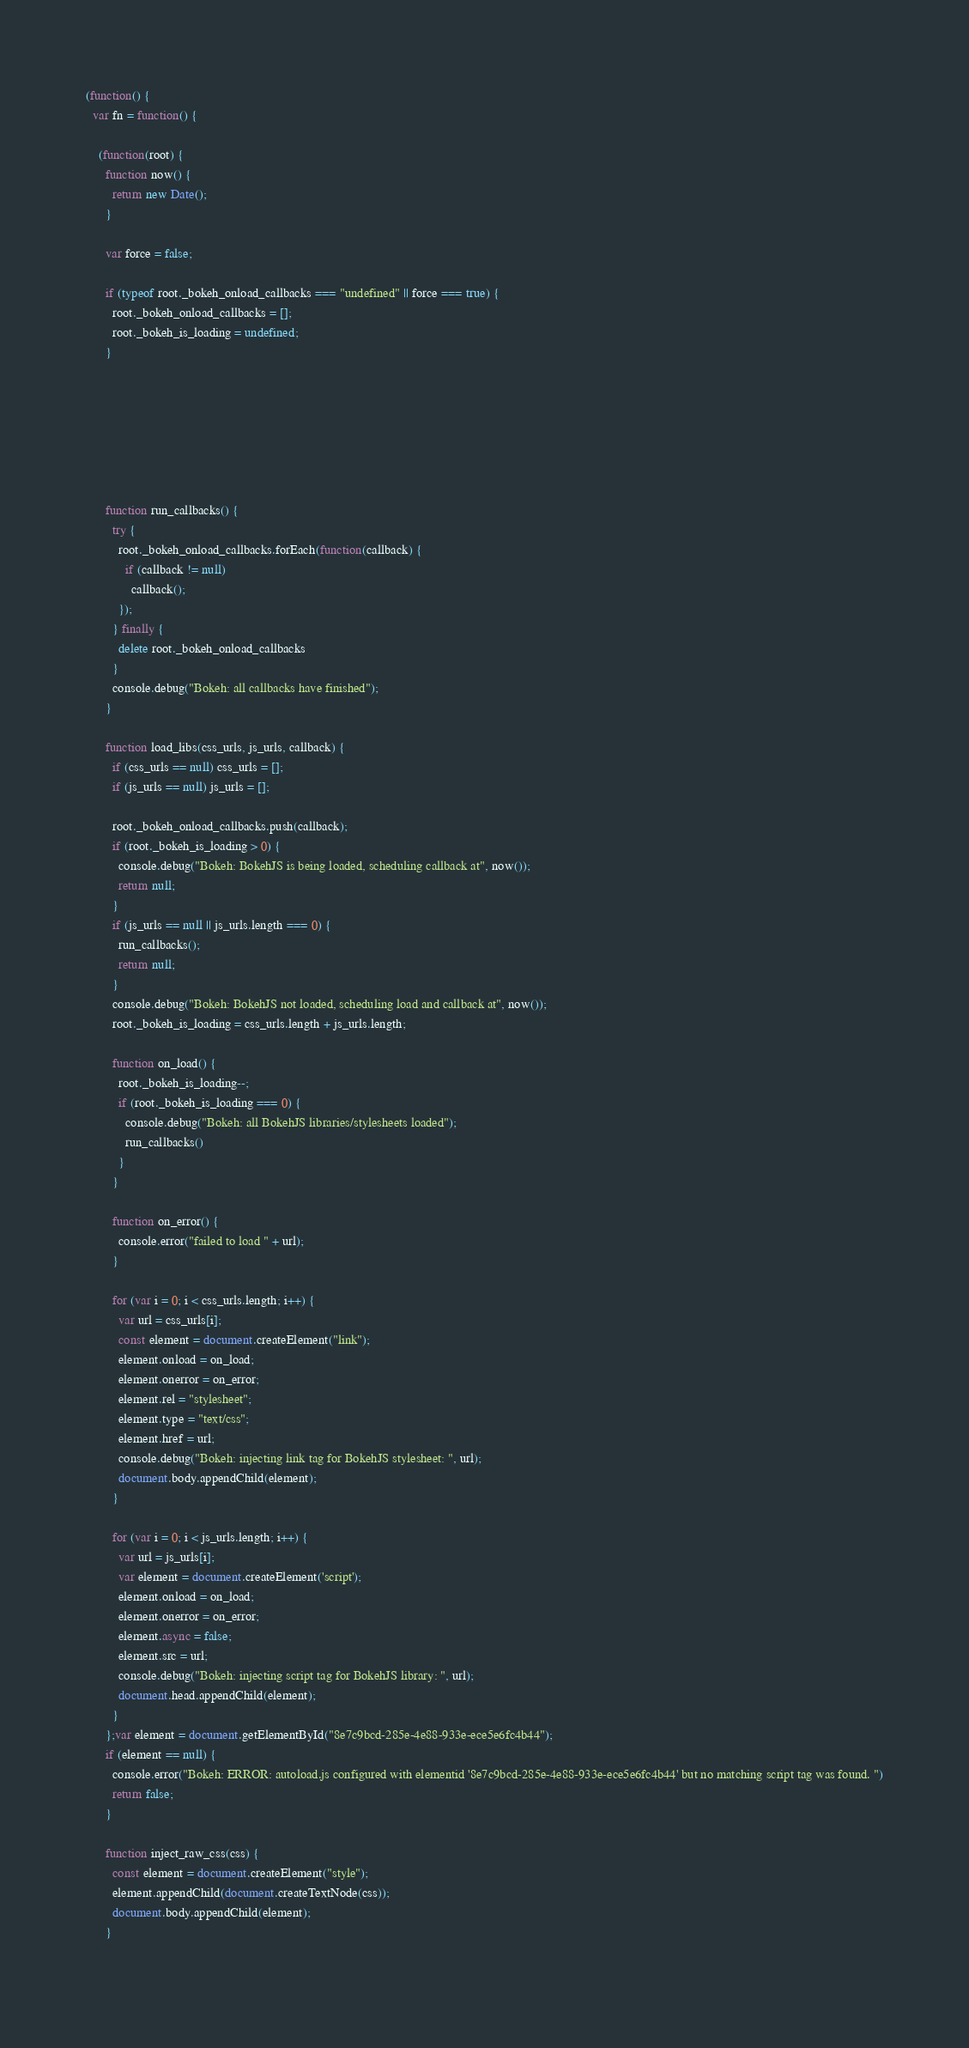Convert code to text. <code><loc_0><loc_0><loc_500><loc_500><_JavaScript_>(function() {
  var fn = function() {
    
    (function(root) {
      function now() {
        return new Date();
      }
    
      var force = false;
    
      if (typeof root._bokeh_onload_callbacks === "undefined" || force === true) {
        root._bokeh_onload_callbacks = [];
        root._bokeh_is_loading = undefined;
      }
    
      
      
    
      
      
    
      function run_callbacks() {
        try {
          root._bokeh_onload_callbacks.forEach(function(callback) {
            if (callback != null)
              callback();
          });
        } finally {
          delete root._bokeh_onload_callbacks
        }
        console.debug("Bokeh: all callbacks have finished");
      }
    
      function load_libs(css_urls, js_urls, callback) {
        if (css_urls == null) css_urls = [];
        if (js_urls == null) js_urls = [];
    
        root._bokeh_onload_callbacks.push(callback);
        if (root._bokeh_is_loading > 0) {
          console.debug("Bokeh: BokehJS is being loaded, scheduling callback at", now());
          return null;
        }
        if (js_urls == null || js_urls.length === 0) {
          run_callbacks();
          return null;
        }
        console.debug("Bokeh: BokehJS not loaded, scheduling load and callback at", now());
        root._bokeh_is_loading = css_urls.length + js_urls.length;
    
        function on_load() {
          root._bokeh_is_loading--;
          if (root._bokeh_is_loading === 0) {
            console.debug("Bokeh: all BokehJS libraries/stylesheets loaded");
            run_callbacks()
          }
        }
    
        function on_error() {
          console.error("failed to load " + url);
        }
    
        for (var i = 0; i < css_urls.length; i++) {
          var url = css_urls[i];
          const element = document.createElement("link");
          element.onload = on_load;
          element.onerror = on_error;
          element.rel = "stylesheet";
          element.type = "text/css";
          element.href = url;
          console.debug("Bokeh: injecting link tag for BokehJS stylesheet: ", url);
          document.body.appendChild(element);
        }
    
        for (var i = 0; i < js_urls.length; i++) {
          var url = js_urls[i];
          var element = document.createElement('script');
          element.onload = on_load;
          element.onerror = on_error;
          element.async = false;
          element.src = url;
          console.debug("Bokeh: injecting script tag for BokehJS library: ", url);
          document.head.appendChild(element);
        }
      };var element = document.getElementById("8e7c9bcd-285e-4e88-933e-ece5e6fc4b44");
      if (element == null) {
        console.error("Bokeh: ERROR: autoload.js configured with elementid '8e7c9bcd-285e-4e88-933e-ece5e6fc4b44' but no matching script tag was found. ")
        return false;
      }
    
      function inject_raw_css(css) {
        const element = document.createElement("style");
        element.appendChild(document.createTextNode(css));
        document.body.appendChild(element);
      }
    </code> 